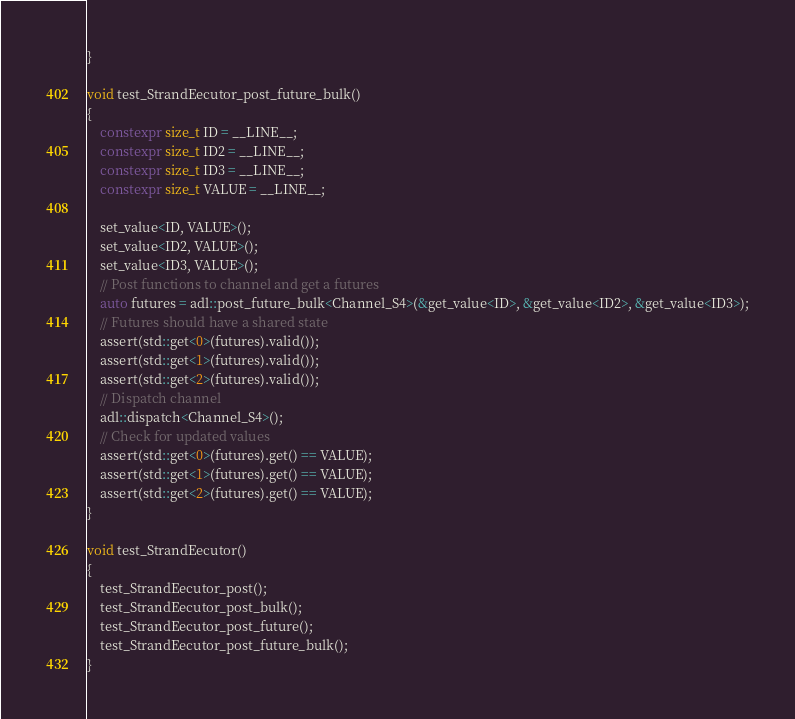Convert code to text. <code><loc_0><loc_0><loc_500><loc_500><_C++_>}

void test_StrandEecutor_post_future_bulk()
{
	constexpr size_t ID = __LINE__;
	constexpr size_t ID2 = __LINE__;
	constexpr size_t ID3 = __LINE__;
	constexpr size_t VALUE = __LINE__;

	set_value<ID, VALUE>();
	set_value<ID2, VALUE>();
	set_value<ID3, VALUE>();
	// Post functions to channel and get a futures
	auto futures = adl::post_future_bulk<Channel_S4>(&get_value<ID>, &get_value<ID2>, &get_value<ID3>);
	// Futures should have a shared state
	assert(std::get<0>(futures).valid());
	assert(std::get<1>(futures).valid());
	assert(std::get<2>(futures).valid());
	// Dispatch channel
	adl::dispatch<Channel_S4>();
	// Check for updated values
	assert(std::get<0>(futures).get() == VALUE);
	assert(std::get<1>(futures).get() == VALUE);
	assert(std::get<2>(futures).get() == VALUE);
}

void test_StrandEecutor()
{
	test_StrandEecutor_post();
	test_StrandEecutor_post_bulk();
	test_StrandEecutor_post_future();
	test_StrandEecutor_post_future_bulk();
}</code> 